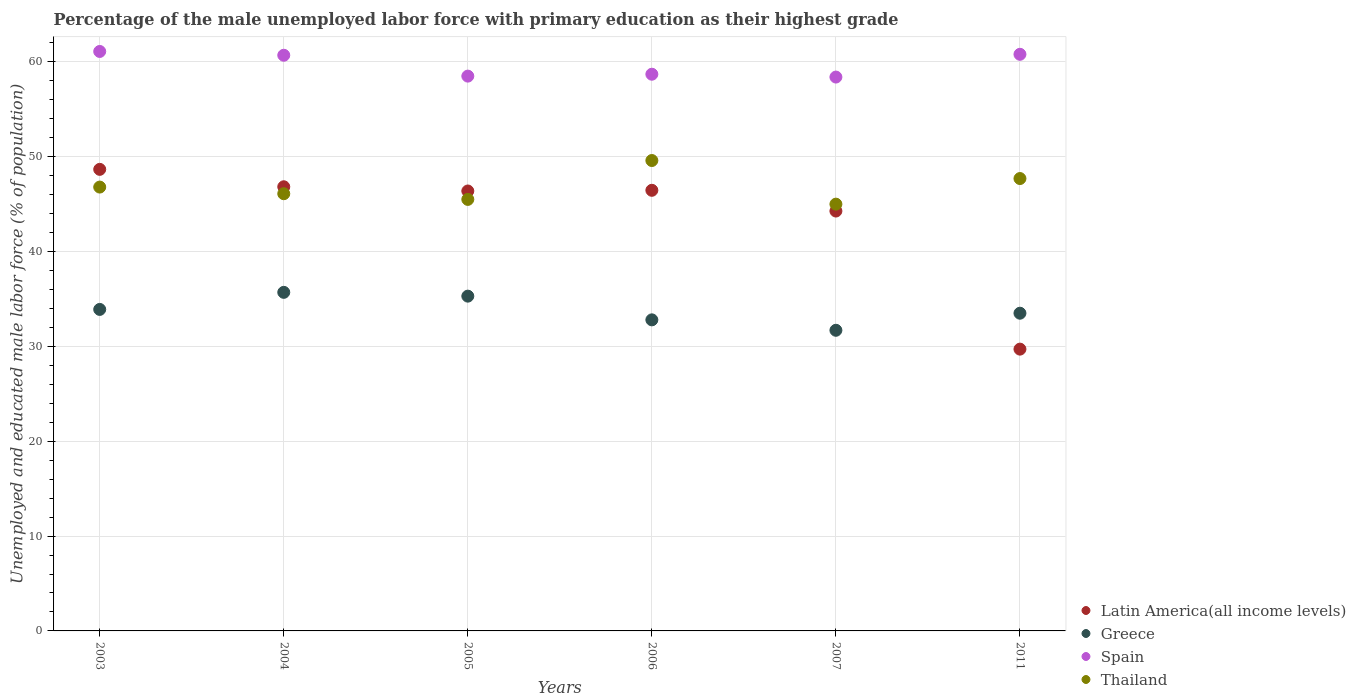What is the percentage of the unemployed male labor force with primary education in Greece in 2003?
Provide a succinct answer. 33.9. Across all years, what is the maximum percentage of the unemployed male labor force with primary education in Thailand?
Provide a succinct answer. 49.6. Across all years, what is the minimum percentage of the unemployed male labor force with primary education in Greece?
Your answer should be compact. 31.7. In which year was the percentage of the unemployed male labor force with primary education in Thailand maximum?
Offer a very short reply. 2006. What is the total percentage of the unemployed male labor force with primary education in Spain in the graph?
Offer a terse response. 358.2. What is the difference between the percentage of the unemployed male labor force with primary education in Latin America(all income levels) in 2005 and that in 2011?
Provide a short and direct response. 16.67. What is the difference between the percentage of the unemployed male labor force with primary education in Greece in 2011 and the percentage of the unemployed male labor force with primary education in Latin America(all income levels) in 2005?
Your answer should be very brief. -12.89. What is the average percentage of the unemployed male labor force with primary education in Thailand per year?
Provide a short and direct response. 46.78. In the year 2003, what is the difference between the percentage of the unemployed male labor force with primary education in Thailand and percentage of the unemployed male labor force with primary education in Greece?
Provide a short and direct response. 12.9. In how many years, is the percentage of the unemployed male labor force with primary education in Thailand greater than 42 %?
Provide a succinct answer. 6. What is the ratio of the percentage of the unemployed male labor force with primary education in Spain in 2005 to that in 2007?
Keep it short and to the point. 1. Is the percentage of the unemployed male labor force with primary education in Greece in 2004 less than that in 2005?
Make the answer very short. No. Is the difference between the percentage of the unemployed male labor force with primary education in Thailand in 2005 and 2006 greater than the difference between the percentage of the unemployed male labor force with primary education in Greece in 2005 and 2006?
Your answer should be compact. No. What is the difference between the highest and the second highest percentage of the unemployed male labor force with primary education in Greece?
Offer a terse response. 0.4. What is the difference between the highest and the lowest percentage of the unemployed male labor force with primary education in Thailand?
Keep it short and to the point. 4.6. Is it the case that in every year, the sum of the percentage of the unemployed male labor force with primary education in Spain and percentage of the unemployed male labor force with primary education in Greece  is greater than the sum of percentage of the unemployed male labor force with primary education in Latin America(all income levels) and percentage of the unemployed male labor force with primary education in Thailand?
Your answer should be compact. Yes. Is it the case that in every year, the sum of the percentage of the unemployed male labor force with primary education in Latin America(all income levels) and percentage of the unemployed male labor force with primary education in Thailand  is greater than the percentage of the unemployed male labor force with primary education in Spain?
Make the answer very short. Yes. How many years are there in the graph?
Your response must be concise. 6. Are the values on the major ticks of Y-axis written in scientific E-notation?
Make the answer very short. No. Does the graph contain any zero values?
Offer a terse response. No. Does the graph contain grids?
Give a very brief answer. Yes. How many legend labels are there?
Provide a succinct answer. 4. How are the legend labels stacked?
Your response must be concise. Vertical. What is the title of the graph?
Make the answer very short. Percentage of the male unemployed labor force with primary education as their highest grade. What is the label or title of the X-axis?
Ensure brevity in your answer.  Years. What is the label or title of the Y-axis?
Offer a very short reply. Unemployed and educated male labor force (% of population). What is the Unemployed and educated male labor force (% of population) of Latin America(all income levels) in 2003?
Offer a very short reply. 48.67. What is the Unemployed and educated male labor force (% of population) in Greece in 2003?
Offer a very short reply. 33.9. What is the Unemployed and educated male labor force (% of population) of Spain in 2003?
Offer a terse response. 61.1. What is the Unemployed and educated male labor force (% of population) of Thailand in 2003?
Provide a short and direct response. 46.8. What is the Unemployed and educated male labor force (% of population) in Latin America(all income levels) in 2004?
Make the answer very short. 46.83. What is the Unemployed and educated male labor force (% of population) of Greece in 2004?
Keep it short and to the point. 35.7. What is the Unemployed and educated male labor force (% of population) in Spain in 2004?
Your response must be concise. 60.7. What is the Unemployed and educated male labor force (% of population) of Thailand in 2004?
Give a very brief answer. 46.1. What is the Unemployed and educated male labor force (% of population) of Latin America(all income levels) in 2005?
Your answer should be compact. 46.39. What is the Unemployed and educated male labor force (% of population) of Greece in 2005?
Offer a terse response. 35.3. What is the Unemployed and educated male labor force (% of population) of Spain in 2005?
Your answer should be compact. 58.5. What is the Unemployed and educated male labor force (% of population) of Thailand in 2005?
Give a very brief answer. 45.5. What is the Unemployed and educated male labor force (% of population) in Latin America(all income levels) in 2006?
Give a very brief answer. 46.46. What is the Unemployed and educated male labor force (% of population) in Greece in 2006?
Ensure brevity in your answer.  32.8. What is the Unemployed and educated male labor force (% of population) of Spain in 2006?
Provide a short and direct response. 58.7. What is the Unemployed and educated male labor force (% of population) in Thailand in 2006?
Offer a very short reply. 49.6. What is the Unemployed and educated male labor force (% of population) in Latin America(all income levels) in 2007?
Your answer should be compact. 44.27. What is the Unemployed and educated male labor force (% of population) of Greece in 2007?
Your answer should be compact. 31.7. What is the Unemployed and educated male labor force (% of population) of Spain in 2007?
Keep it short and to the point. 58.4. What is the Unemployed and educated male labor force (% of population) of Thailand in 2007?
Offer a terse response. 45. What is the Unemployed and educated male labor force (% of population) of Latin America(all income levels) in 2011?
Provide a short and direct response. 29.71. What is the Unemployed and educated male labor force (% of population) in Greece in 2011?
Ensure brevity in your answer.  33.5. What is the Unemployed and educated male labor force (% of population) of Spain in 2011?
Provide a succinct answer. 60.8. What is the Unemployed and educated male labor force (% of population) in Thailand in 2011?
Make the answer very short. 47.7. Across all years, what is the maximum Unemployed and educated male labor force (% of population) of Latin America(all income levels)?
Provide a succinct answer. 48.67. Across all years, what is the maximum Unemployed and educated male labor force (% of population) of Greece?
Provide a short and direct response. 35.7. Across all years, what is the maximum Unemployed and educated male labor force (% of population) of Spain?
Offer a very short reply. 61.1. Across all years, what is the maximum Unemployed and educated male labor force (% of population) of Thailand?
Your answer should be very brief. 49.6. Across all years, what is the minimum Unemployed and educated male labor force (% of population) in Latin America(all income levels)?
Your answer should be compact. 29.71. Across all years, what is the minimum Unemployed and educated male labor force (% of population) of Greece?
Give a very brief answer. 31.7. Across all years, what is the minimum Unemployed and educated male labor force (% of population) of Spain?
Your response must be concise. 58.4. Across all years, what is the minimum Unemployed and educated male labor force (% of population) of Thailand?
Provide a short and direct response. 45. What is the total Unemployed and educated male labor force (% of population) in Latin America(all income levels) in the graph?
Offer a terse response. 262.33. What is the total Unemployed and educated male labor force (% of population) of Greece in the graph?
Offer a very short reply. 202.9. What is the total Unemployed and educated male labor force (% of population) in Spain in the graph?
Give a very brief answer. 358.2. What is the total Unemployed and educated male labor force (% of population) of Thailand in the graph?
Provide a succinct answer. 280.7. What is the difference between the Unemployed and educated male labor force (% of population) in Latin America(all income levels) in 2003 and that in 2004?
Keep it short and to the point. 1.84. What is the difference between the Unemployed and educated male labor force (% of population) of Spain in 2003 and that in 2004?
Give a very brief answer. 0.4. What is the difference between the Unemployed and educated male labor force (% of population) of Thailand in 2003 and that in 2004?
Make the answer very short. 0.7. What is the difference between the Unemployed and educated male labor force (% of population) of Latin America(all income levels) in 2003 and that in 2005?
Ensure brevity in your answer.  2.28. What is the difference between the Unemployed and educated male labor force (% of population) in Spain in 2003 and that in 2005?
Provide a short and direct response. 2.6. What is the difference between the Unemployed and educated male labor force (% of population) in Latin America(all income levels) in 2003 and that in 2006?
Your response must be concise. 2.21. What is the difference between the Unemployed and educated male labor force (% of population) in Spain in 2003 and that in 2006?
Your response must be concise. 2.4. What is the difference between the Unemployed and educated male labor force (% of population) in Thailand in 2003 and that in 2006?
Make the answer very short. -2.8. What is the difference between the Unemployed and educated male labor force (% of population) of Latin America(all income levels) in 2003 and that in 2007?
Ensure brevity in your answer.  4.4. What is the difference between the Unemployed and educated male labor force (% of population) in Greece in 2003 and that in 2007?
Your response must be concise. 2.2. What is the difference between the Unemployed and educated male labor force (% of population) of Spain in 2003 and that in 2007?
Provide a short and direct response. 2.7. What is the difference between the Unemployed and educated male labor force (% of population) of Latin America(all income levels) in 2003 and that in 2011?
Make the answer very short. 18.96. What is the difference between the Unemployed and educated male labor force (% of population) in Latin America(all income levels) in 2004 and that in 2005?
Provide a short and direct response. 0.45. What is the difference between the Unemployed and educated male labor force (% of population) of Spain in 2004 and that in 2005?
Provide a short and direct response. 2.2. What is the difference between the Unemployed and educated male labor force (% of population) in Latin America(all income levels) in 2004 and that in 2006?
Your response must be concise. 0.37. What is the difference between the Unemployed and educated male labor force (% of population) of Greece in 2004 and that in 2006?
Your answer should be very brief. 2.9. What is the difference between the Unemployed and educated male labor force (% of population) of Spain in 2004 and that in 2006?
Give a very brief answer. 2. What is the difference between the Unemployed and educated male labor force (% of population) in Latin America(all income levels) in 2004 and that in 2007?
Make the answer very short. 2.56. What is the difference between the Unemployed and educated male labor force (% of population) of Greece in 2004 and that in 2007?
Keep it short and to the point. 4. What is the difference between the Unemployed and educated male labor force (% of population) of Spain in 2004 and that in 2007?
Offer a very short reply. 2.3. What is the difference between the Unemployed and educated male labor force (% of population) in Latin America(all income levels) in 2004 and that in 2011?
Offer a very short reply. 17.12. What is the difference between the Unemployed and educated male labor force (% of population) of Spain in 2004 and that in 2011?
Ensure brevity in your answer.  -0.1. What is the difference between the Unemployed and educated male labor force (% of population) in Latin America(all income levels) in 2005 and that in 2006?
Provide a succinct answer. -0.07. What is the difference between the Unemployed and educated male labor force (% of population) in Greece in 2005 and that in 2006?
Offer a terse response. 2.5. What is the difference between the Unemployed and educated male labor force (% of population) of Thailand in 2005 and that in 2006?
Provide a succinct answer. -4.1. What is the difference between the Unemployed and educated male labor force (% of population) in Latin America(all income levels) in 2005 and that in 2007?
Offer a terse response. 2.11. What is the difference between the Unemployed and educated male labor force (% of population) in Spain in 2005 and that in 2007?
Your answer should be compact. 0.1. What is the difference between the Unemployed and educated male labor force (% of population) in Latin America(all income levels) in 2005 and that in 2011?
Make the answer very short. 16.67. What is the difference between the Unemployed and educated male labor force (% of population) of Greece in 2005 and that in 2011?
Make the answer very short. 1.8. What is the difference between the Unemployed and educated male labor force (% of population) in Latin America(all income levels) in 2006 and that in 2007?
Your response must be concise. 2.19. What is the difference between the Unemployed and educated male labor force (% of population) in Spain in 2006 and that in 2007?
Ensure brevity in your answer.  0.3. What is the difference between the Unemployed and educated male labor force (% of population) in Thailand in 2006 and that in 2007?
Offer a terse response. 4.6. What is the difference between the Unemployed and educated male labor force (% of population) of Latin America(all income levels) in 2006 and that in 2011?
Offer a terse response. 16.75. What is the difference between the Unemployed and educated male labor force (% of population) of Greece in 2006 and that in 2011?
Keep it short and to the point. -0.7. What is the difference between the Unemployed and educated male labor force (% of population) of Spain in 2006 and that in 2011?
Your response must be concise. -2.1. What is the difference between the Unemployed and educated male labor force (% of population) of Latin America(all income levels) in 2007 and that in 2011?
Offer a very short reply. 14.56. What is the difference between the Unemployed and educated male labor force (% of population) of Greece in 2007 and that in 2011?
Your answer should be very brief. -1.8. What is the difference between the Unemployed and educated male labor force (% of population) in Latin America(all income levels) in 2003 and the Unemployed and educated male labor force (% of population) in Greece in 2004?
Keep it short and to the point. 12.97. What is the difference between the Unemployed and educated male labor force (% of population) of Latin America(all income levels) in 2003 and the Unemployed and educated male labor force (% of population) of Spain in 2004?
Your answer should be compact. -12.03. What is the difference between the Unemployed and educated male labor force (% of population) in Latin America(all income levels) in 2003 and the Unemployed and educated male labor force (% of population) in Thailand in 2004?
Offer a very short reply. 2.57. What is the difference between the Unemployed and educated male labor force (% of population) of Greece in 2003 and the Unemployed and educated male labor force (% of population) of Spain in 2004?
Your answer should be very brief. -26.8. What is the difference between the Unemployed and educated male labor force (% of population) in Spain in 2003 and the Unemployed and educated male labor force (% of population) in Thailand in 2004?
Give a very brief answer. 15. What is the difference between the Unemployed and educated male labor force (% of population) of Latin America(all income levels) in 2003 and the Unemployed and educated male labor force (% of population) of Greece in 2005?
Keep it short and to the point. 13.37. What is the difference between the Unemployed and educated male labor force (% of population) in Latin America(all income levels) in 2003 and the Unemployed and educated male labor force (% of population) in Spain in 2005?
Your answer should be compact. -9.83. What is the difference between the Unemployed and educated male labor force (% of population) of Latin America(all income levels) in 2003 and the Unemployed and educated male labor force (% of population) of Thailand in 2005?
Your response must be concise. 3.17. What is the difference between the Unemployed and educated male labor force (% of population) in Greece in 2003 and the Unemployed and educated male labor force (% of population) in Spain in 2005?
Your answer should be very brief. -24.6. What is the difference between the Unemployed and educated male labor force (% of population) of Spain in 2003 and the Unemployed and educated male labor force (% of population) of Thailand in 2005?
Provide a succinct answer. 15.6. What is the difference between the Unemployed and educated male labor force (% of population) in Latin America(all income levels) in 2003 and the Unemployed and educated male labor force (% of population) in Greece in 2006?
Provide a short and direct response. 15.87. What is the difference between the Unemployed and educated male labor force (% of population) of Latin America(all income levels) in 2003 and the Unemployed and educated male labor force (% of population) of Spain in 2006?
Give a very brief answer. -10.03. What is the difference between the Unemployed and educated male labor force (% of population) in Latin America(all income levels) in 2003 and the Unemployed and educated male labor force (% of population) in Thailand in 2006?
Offer a very short reply. -0.93. What is the difference between the Unemployed and educated male labor force (% of population) of Greece in 2003 and the Unemployed and educated male labor force (% of population) of Spain in 2006?
Ensure brevity in your answer.  -24.8. What is the difference between the Unemployed and educated male labor force (% of population) of Greece in 2003 and the Unemployed and educated male labor force (% of population) of Thailand in 2006?
Offer a terse response. -15.7. What is the difference between the Unemployed and educated male labor force (% of population) of Latin America(all income levels) in 2003 and the Unemployed and educated male labor force (% of population) of Greece in 2007?
Your response must be concise. 16.97. What is the difference between the Unemployed and educated male labor force (% of population) of Latin America(all income levels) in 2003 and the Unemployed and educated male labor force (% of population) of Spain in 2007?
Provide a short and direct response. -9.73. What is the difference between the Unemployed and educated male labor force (% of population) in Latin America(all income levels) in 2003 and the Unemployed and educated male labor force (% of population) in Thailand in 2007?
Keep it short and to the point. 3.67. What is the difference between the Unemployed and educated male labor force (% of population) in Greece in 2003 and the Unemployed and educated male labor force (% of population) in Spain in 2007?
Your answer should be compact. -24.5. What is the difference between the Unemployed and educated male labor force (% of population) in Latin America(all income levels) in 2003 and the Unemployed and educated male labor force (% of population) in Greece in 2011?
Offer a very short reply. 15.17. What is the difference between the Unemployed and educated male labor force (% of population) of Latin America(all income levels) in 2003 and the Unemployed and educated male labor force (% of population) of Spain in 2011?
Your response must be concise. -12.13. What is the difference between the Unemployed and educated male labor force (% of population) in Latin America(all income levels) in 2003 and the Unemployed and educated male labor force (% of population) in Thailand in 2011?
Your response must be concise. 0.97. What is the difference between the Unemployed and educated male labor force (% of population) in Greece in 2003 and the Unemployed and educated male labor force (% of population) in Spain in 2011?
Offer a terse response. -26.9. What is the difference between the Unemployed and educated male labor force (% of population) of Spain in 2003 and the Unemployed and educated male labor force (% of population) of Thailand in 2011?
Provide a succinct answer. 13.4. What is the difference between the Unemployed and educated male labor force (% of population) in Latin America(all income levels) in 2004 and the Unemployed and educated male labor force (% of population) in Greece in 2005?
Keep it short and to the point. 11.53. What is the difference between the Unemployed and educated male labor force (% of population) in Latin America(all income levels) in 2004 and the Unemployed and educated male labor force (% of population) in Spain in 2005?
Your answer should be very brief. -11.67. What is the difference between the Unemployed and educated male labor force (% of population) of Latin America(all income levels) in 2004 and the Unemployed and educated male labor force (% of population) of Thailand in 2005?
Your answer should be compact. 1.33. What is the difference between the Unemployed and educated male labor force (% of population) in Greece in 2004 and the Unemployed and educated male labor force (% of population) in Spain in 2005?
Ensure brevity in your answer.  -22.8. What is the difference between the Unemployed and educated male labor force (% of population) of Greece in 2004 and the Unemployed and educated male labor force (% of population) of Thailand in 2005?
Give a very brief answer. -9.8. What is the difference between the Unemployed and educated male labor force (% of population) in Latin America(all income levels) in 2004 and the Unemployed and educated male labor force (% of population) in Greece in 2006?
Provide a short and direct response. 14.03. What is the difference between the Unemployed and educated male labor force (% of population) in Latin America(all income levels) in 2004 and the Unemployed and educated male labor force (% of population) in Spain in 2006?
Offer a very short reply. -11.87. What is the difference between the Unemployed and educated male labor force (% of population) of Latin America(all income levels) in 2004 and the Unemployed and educated male labor force (% of population) of Thailand in 2006?
Ensure brevity in your answer.  -2.77. What is the difference between the Unemployed and educated male labor force (% of population) of Greece in 2004 and the Unemployed and educated male labor force (% of population) of Spain in 2006?
Keep it short and to the point. -23. What is the difference between the Unemployed and educated male labor force (% of population) of Spain in 2004 and the Unemployed and educated male labor force (% of population) of Thailand in 2006?
Your answer should be compact. 11.1. What is the difference between the Unemployed and educated male labor force (% of population) in Latin America(all income levels) in 2004 and the Unemployed and educated male labor force (% of population) in Greece in 2007?
Offer a very short reply. 15.13. What is the difference between the Unemployed and educated male labor force (% of population) in Latin America(all income levels) in 2004 and the Unemployed and educated male labor force (% of population) in Spain in 2007?
Offer a very short reply. -11.57. What is the difference between the Unemployed and educated male labor force (% of population) of Latin America(all income levels) in 2004 and the Unemployed and educated male labor force (% of population) of Thailand in 2007?
Your answer should be compact. 1.83. What is the difference between the Unemployed and educated male labor force (% of population) of Greece in 2004 and the Unemployed and educated male labor force (% of population) of Spain in 2007?
Give a very brief answer. -22.7. What is the difference between the Unemployed and educated male labor force (% of population) of Greece in 2004 and the Unemployed and educated male labor force (% of population) of Thailand in 2007?
Offer a very short reply. -9.3. What is the difference between the Unemployed and educated male labor force (% of population) of Spain in 2004 and the Unemployed and educated male labor force (% of population) of Thailand in 2007?
Provide a short and direct response. 15.7. What is the difference between the Unemployed and educated male labor force (% of population) of Latin America(all income levels) in 2004 and the Unemployed and educated male labor force (% of population) of Greece in 2011?
Your answer should be very brief. 13.33. What is the difference between the Unemployed and educated male labor force (% of population) of Latin America(all income levels) in 2004 and the Unemployed and educated male labor force (% of population) of Spain in 2011?
Offer a terse response. -13.97. What is the difference between the Unemployed and educated male labor force (% of population) of Latin America(all income levels) in 2004 and the Unemployed and educated male labor force (% of population) of Thailand in 2011?
Provide a short and direct response. -0.87. What is the difference between the Unemployed and educated male labor force (% of population) in Greece in 2004 and the Unemployed and educated male labor force (% of population) in Spain in 2011?
Make the answer very short. -25.1. What is the difference between the Unemployed and educated male labor force (% of population) in Spain in 2004 and the Unemployed and educated male labor force (% of population) in Thailand in 2011?
Your response must be concise. 13. What is the difference between the Unemployed and educated male labor force (% of population) of Latin America(all income levels) in 2005 and the Unemployed and educated male labor force (% of population) of Greece in 2006?
Your response must be concise. 13.59. What is the difference between the Unemployed and educated male labor force (% of population) in Latin America(all income levels) in 2005 and the Unemployed and educated male labor force (% of population) in Spain in 2006?
Offer a terse response. -12.31. What is the difference between the Unemployed and educated male labor force (% of population) in Latin America(all income levels) in 2005 and the Unemployed and educated male labor force (% of population) in Thailand in 2006?
Ensure brevity in your answer.  -3.21. What is the difference between the Unemployed and educated male labor force (% of population) of Greece in 2005 and the Unemployed and educated male labor force (% of population) of Spain in 2006?
Ensure brevity in your answer.  -23.4. What is the difference between the Unemployed and educated male labor force (% of population) in Greece in 2005 and the Unemployed and educated male labor force (% of population) in Thailand in 2006?
Keep it short and to the point. -14.3. What is the difference between the Unemployed and educated male labor force (% of population) in Spain in 2005 and the Unemployed and educated male labor force (% of population) in Thailand in 2006?
Offer a very short reply. 8.9. What is the difference between the Unemployed and educated male labor force (% of population) of Latin America(all income levels) in 2005 and the Unemployed and educated male labor force (% of population) of Greece in 2007?
Offer a very short reply. 14.69. What is the difference between the Unemployed and educated male labor force (% of population) of Latin America(all income levels) in 2005 and the Unemployed and educated male labor force (% of population) of Spain in 2007?
Provide a short and direct response. -12.01. What is the difference between the Unemployed and educated male labor force (% of population) in Latin America(all income levels) in 2005 and the Unemployed and educated male labor force (% of population) in Thailand in 2007?
Give a very brief answer. 1.39. What is the difference between the Unemployed and educated male labor force (% of population) of Greece in 2005 and the Unemployed and educated male labor force (% of population) of Spain in 2007?
Your answer should be compact. -23.1. What is the difference between the Unemployed and educated male labor force (% of population) of Latin America(all income levels) in 2005 and the Unemployed and educated male labor force (% of population) of Greece in 2011?
Provide a short and direct response. 12.89. What is the difference between the Unemployed and educated male labor force (% of population) in Latin America(all income levels) in 2005 and the Unemployed and educated male labor force (% of population) in Spain in 2011?
Your answer should be very brief. -14.41. What is the difference between the Unemployed and educated male labor force (% of population) in Latin America(all income levels) in 2005 and the Unemployed and educated male labor force (% of population) in Thailand in 2011?
Offer a terse response. -1.31. What is the difference between the Unemployed and educated male labor force (% of population) in Greece in 2005 and the Unemployed and educated male labor force (% of population) in Spain in 2011?
Offer a terse response. -25.5. What is the difference between the Unemployed and educated male labor force (% of population) of Greece in 2005 and the Unemployed and educated male labor force (% of population) of Thailand in 2011?
Offer a very short reply. -12.4. What is the difference between the Unemployed and educated male labor force (% of population) in Spain in 2005 and the Unemployed and educated male labor force (% of population) in Thailand in 2011?
Make the answer very short. 10.8. What is the difference between the Unemployed and educated male labor force (% of population) in Latin America(all income levels) in 2006 and the Unemployed and educated male labor force (% of population) in Greece in 2007?
Keep it short and to the point. 14.76. What is the difference between the Unemployed and educated male labor force (% of population) in Latin America(all income levels) in 2006 and the Unemployed and educated male labor force (% of population) in Spain in 2007?
Your answer should be very brief. -11.94. What is the difference between the Unemployed and educated male labor force (% of population) of Latin America(all income levels) in 2006 and the Unemployed and educated male labor force (% of population) of Thailand in 2007?
Your answer should be very brief. 1.46. What is the difference between the Unemployed and educated male labor force (% of population) in Greece in 2006 and the Unemployed and educated male labor force (% of population) in Spain in 2007?
Your answer should be compact. -25.6. What is the difference between the Unemployed and educated male labor force (% of population) in Greece in 2006 and the Unemployed and educated male labor force (% of population) in Thailand in 2007?
Keep it short and to the point. -12.2. What is the difference between the Unemployed and educated male labor force (% of population) in Spain in 2006 and the Unemployed and educated male labor force (% of population) in Thailand in 2007?
Offer a very short reply. 13.7. What is the difference between the Unemployed and educated male labor force (% of population) in Latin America(all income levels) in 2006 and the Unemployed and educated male labor force (% of population) in Greece in 2011?
Keep it short and to the point. 12.96. What is the difference between the Unemployed and educated male labor force (% of population) of Latin America(all income levels) in 2006 and the Unemployed and educated male labor force (% of population) of Spain in 2011?
Provide a short and direct response. -14.34. What is the difference between the Unemployed and educated male labor force (% of population) in Latin America(all income levels) in 2006 and the Unemployed and educated male labor force (% of population) in Thailand in 2011?
Offer a very short reply. -1.24. What is the difference between the Unemployed and educated male labor force (% of population) in Greece in 2006 and the Unemployed and educated male labor force (% of population) in Thailand in 2011?
Make the answer very short. -14.9. What is the difference between the Unemployed and educated male labor force (% of population) in Latin America(all income levels) in 2007 and the Unemployed and educated male labor force (% of population) in Greece in 2011?
Your answer should be very brief. 10.77. What is the difference between the Unemployed and educated male labor force (% of population) of Latin America(all income levels) in 2007 and the Unemployed and educated male labor force (% of population) of Spain in 2011?
Offer a very short reply. -16.53. What is the difference between the Unemployed and educated male labor force (% of population) in Latin America(all income levels) in 2007 and the Unemployed and educated male labor force (% of population) in Thailand in 2011?
Give a very brief answer. -3.43. What is the difference between the Unemployed and educated male labor force (% of population) in Greece in 2007 and the Unemployed and educated male labor force (% of population) in Spain in 2011?
Keep it short and to the point. -29.1. What is the difference between the Unemployed and educated male labor force (% of population) of Greece in 2007 and the Unemployed and educated male labor force (% of population) of Thailand in 2011?
Provide a succinct answer. -16. What is the average Unemployed and educated male labor force (% of population) of Latin America(all income levels) per year?
Your answer should be compact. 43.72. What is the average Unemployed and educated male labor force (% of population) in Greece per year?
Offer a terse response. 33.82. What is the average Unemployed and educated male labor force (% of population) of Spain per year?
Your response must be concise. 59.7. What is the average Unemployed and educated male labor force (% of population) in Thailand per year?
Your answer should be very brief. 46.78. In the year 2003, what is the difference between the Unemployed and educated male labor force (% of population) of Latin America(all income levels) and Unemployed and educated male labor force (% of population) of Greece?
Your response must be concise. 14.77. In the year 2003, what is the difference between the Unemployed and educated male labor force (% of population) in Latin America(all income levels) and Unemployed and educated male labor force (% of population) in Spain?
Your answer should be very brief. -12.43. In the year 2003, what is the difference between the Unemployed and educated male labor force (% of population) in Latin America(all income levels) and Unemployed and educated male labor force (% of population) in Thailand?
Give a very brief answer. 1.87. In the year 2003, what is the difference between the Unemployed and educated male labor force (% of population) of Greece and Unemployed and educated male labor force (% of population) of Spain?
Provide a succinct answer. -27.2. In the year 2004, what is the difference between the Unemployed and educated male labor force (% of population) in Latin America(all income levels) and Unemployed and educated male labor force (% of population) in Greece?
Your answer should be very brief. 11.13. In the year 2004, what is the difference between the Unemployed and educated male labor force (% of population) of Latin America(all income levels) and Unemployed and educated male labor force (% of population) of Spain?
Provide a short and direct response. -13.87. In the year 2004, what is the difference between the Unemployed and educated male labor force (% of population) of Latin America(all income levels) and Unemployed and educated male labor force (% of population) of Thailand?
Ensure brevity in your answer.  0.73. In the year 2004, what is the difference between the Unemployed and educated male labor force (% of population) in Greece and Unemployed and educated male labor force (% of population) in Spain?
Your response must be concise. -25. In the year 2004, what is the difference between the Unemployed and educated male labor force (% of population) in Spain and Unemployed and educated male labor force (% of population) in Thailand?
Your answer should be very brief. 14.6. In the year 2005, what is the difference between the Unemployed and educated male labor force (% of population) in Latin America(all income levels) and Unemployed and educated male labor force (% of population) in Greece?
Ensure brevity in your answer.  11.09. In the year 2005, what is the difference between the Unemployed and educated male labor force (% of population) in Latin America(all income levels) and Unemployed and educated male labor force (% of population) in Spain?
Your answer should be compact. -12.11. In the year 2005, what is the difference between the Unemployed and educated male labor force (% of population) of Latin America(all income levels) and Unemployed and educated male labor force (% of population) of Thailand?
Your answer should be very brief. 0.89. In the year 2005, what is the difference between the Unemployed and educated male labor force (% of population) in Greece and Unemployed and educated male labor force (% of population) in Spain?
Make the answer very short. -23.2. In the year 2006, what is the difference between the Unemployed and educated male labor force (% of population) of Latin America(all income levels) and Unemployed and educated male labor force (% of population) of Greece?
Make the answer very short. 13.66. In the year 2006, what is the difference between the Unemployed and educated male labor force (% of population) in Latin America(all income levels) and Unemployed and educated male labor force (% of population) in Spain?
Your answer should be very brief. -12.24. In the year 2006, what is the difference between the Unemployed and educated male labor force (% of population) in Latin America(all income levels) and Unemployed and educated male labor force (% of population) in Thailand?
Provide a short and direct response. -3.14. In the year 2006, what is the difference between the Unemployed and educated male labor force (% of population) of Greece and Unemployed and educated male labor force (% of population) of Spain?
Provide a short and direct response. -25.9. In the year 2006, what is the difference between the Unemployed and educated male labor force (% of population) in Greece and Unemployed and educated male labor force (% of population) in Thailand?
Offer a very short reply. -16.8. In the year 2007, what is the difference between the Unemployed and educated male labor force (% of population) in Latin America(all income levels) and Unemployed and educated male labor force (% of population) in Greece?
Your answer should be compact. 12.57. In the year 2007, what is the difference between the Unemployed and educated male labor force (% of population) in Latin America(all income levels) and Unemployed and educated male labor force (% of population) in Spain?
Your answer should be very brief. -14.13. In the year 2007, what is the difference between the Unemployed and educated male labor force (% of population) of Latin America(all income levels) and Unemployed and educated male labor force (% of population) of Thailand?
Provide a succinct answer. -0.73. In the year 2007, what is the difference between the Unemployed and educated male labor force (% of population) in Greece and Unemployed and educated male labor force (% of population) in Spain?
Your answer should be compact. -26.7. In the year 2007, what is the difference between the Unemployed and educated male labor force (% of population) in Greece and Unemployed and educated male labor force (% of population) in Thailand?
Offer a terse response. -13.3. In the year 2007, what is the difference between the Unemployed and educated male labor force (% of population) in Spain and Unemployed and educated male labor force (% of population) in Thailand?
Provide a short and direct response. 13.4. In the year 2011, what is the difference between the Unemployed and educated male labor force (% of population) in Latin America(all income levels) and Unemployed and educated male labor force (% of population) in Greece?
Offer a very short reply. -3.79. In the year 2011, what is the difference between the Unemployed and educated male labor force (% of population) of Latin America(all income levels) and Unemployed and educated male labor force (% of population) of Spain?
Provide a succinct answer. -31.09. In the year 2011, what is the difference between the Unemployed and educated male labor force (% of population) of Latin America(all income levels) and Unemployed and educated male labor force (% of population) of Thailand?
Make the answer very short. -17.99. In the year 2011, what is the difference between the Unemployed and educated male labor force (% of population) of Greece and Unemployed and educated male labor force (% of population) of Spain?
Provide a short and direct response. -27.3. What is the ratio of the Unemployed and educated male labor force (% of population) in Latin America(all income levels) in 2003 to that in 2004?
Your response must be concise. 1.04. What is the ratio of the Unemployed and educated male labor force (% of population) in Greece in 2003 to that in 2004?
Offer a terse response. 0.95. What is the ratio of the Unemployed and educated male labor force (% of population) of Spain in 2003 to that in 2004?
Your answer should be very brief. 1.01. What is the ratio of the Unemployed and educated male labor force (% of population) of Thailand in 2003 to that in 2004?
Ensure brevity in your answer.  1.02. What is the ratio of the Unemployed and educated male labor force (% of population) of Latin America(all income levels) in 2003 to that in 2005?
Offer a very short reply. 1.05. What is the ratio of the Unemployed and educated male labor force (% of population) of Greece in 2003 to that in 2005?
Provide a succinct answer. 0.96. What is the ratio of the Unemployed and educated male labor force (% of population) in Spain in 2003 to that in 2005?
Ensure brevity in your answer.  1.04. What is the ratio of the Unemployed and educated male labor force (% of population) in Thailand in 2003 to that in 2005?
Keep it short and to the point. 1.03. What is the ratio of the Unemployed and educated male labor force (% of population) in Latin America(all income levels) in 2003 to that in 2006?
Your answer should be very brief. 1.05. What is the ratio of the Unemployed and educated male labor force (% of population) in Greece in 2003 to that in 2006?
Keep it short and to the point. 1.03. What is the ratio of the Unemployed and educated male labor force (% of population) in Spain in 2003 to that in 2006?
Ensure brevity in your answer.  1.04. What is the ratio of the Unemployed and educated male labor force (% of population) in Thailand in 2003 to that in 2006?
Provide a succinct answer. 0.94. What is the ratio of the Unemployed and educated male labor force (% of population) in Latin America(all income levels) in 2003 to that in 2007?
Provide a short and direct response. 1.1. What is the ratio of the Unemployed and educated male labor force (% of population) of Greece in 2003 to that in 2007?
Ensure brevity in your answer.  1.07. What is the ratio of the Unemployed and educated male labor force (% of population) of Spain in 2003 to that in 2007?
Ensure brevity in your answer.  1.05. What is the ratio of the Unemployed and educated male labor force (% of population) of Thailand in 2003 to that in 2007?
Make the answer very short. 1.04. What is the ratio of the Unemployed and educated male labor force (% of population) of Latin America(all income levels) in 2003 to that in 2011?
Ensure brevity in your answer.  1.64. What is the ratio of the Unemployed and educated male labor force (% of population) of Greece in 2003 to that in 2011?
Provide a short and direct response. 1.01. What is the ratio of the Unemployed and educated male labor force (% of population) of Spain in 2003 to that in 2011?
Your answer should be compact. 1. What is the ratio of the Unemployed and educated male labor force (% of population) of Thailand in 2003 to that in 2011?
Your answer should be very brief. 0.98. What is the ratio of the Unemployed and educated male labor force (% of population) of Latin America(all income levels) in 2004 to that in 2005?
Your answer should be compact. 1.01. What is the ratio of the Unemployed and educated male labor force (% of population) in Greece in 2004 to that in 2005?
Offer a very short reply. 1.01. What is the ratio of the Unemployed and educated male labor force (% of population) of Spain in 2004 to that in 2005?
Keep it short and to the point. 1.04. What is the ratio of the Unemployed and educated male labor force (% of population) of Thailand in 2004 to that in 2005?
Keep it short and to the point. 1.01. What is the ratio of the Unemployed and educated male labor force (% of population) in Greece in 2004 to that in 2006?
Keep it short and to the point. 1.09. What is the ratio of the Unemployed and educated male labor force (% of population) of Spain in 2004 to that in 2006?
Keep it short and to the point. 1.03. What is the ratio of the Unemployed and educated male labor force (% of population) in Thailand in 2004 to that in 2006?
Your answer should be very brief. 0.93. What is the ratio of the Unemployed and educated male labor force (% of population) of Latin America(all income levels) in 2004 to that in 2007?
Your answer should be very brief. 1.06. What is the ratio of the Unemployed and educated male labor force (% of population) of Greece in 2004 to that in 2007?
Give a very brief answer. 1.13. What is the ratio of the Unemployed and educated male labor force (% of population) of Spain in 2004 to that in 2007?
Your answer should be very brief. 1.04. What is the ratio of the Unemployed and educated male labor force (% of population) of Thailand in 2004 to that in 2007?
Provide a succinct answer. 1.02. What is the ratio of the Unemployed and educated male labor force (% of population) in Latin America(all income levels) in 2004 to that in 2011?
Ensure brevity in your answer.  1.58. What is the ratio of the Unemployed and educated male labor force (% of population) in Greece in 2004 to that in 2011?
Provide a succinct answer. 1.07. What is the ratio of the Unemployed and educated male labor force (% of population) of Spain in 2004 to that in 2011?
Your response must be concise. 1. What is the ratio of the Unemployed and educated male labor force (% of population) in Thailand in 2004 to that in 2011?
Offer a very short reply. 0.97. What is the ratio of the Unemployed and educated male labor force (% of population) of Latin America(all income levels) in 2005 to that in 2006?
Keep it short and to the point. 1. What is the ratio of the Unemployed and educated male labor force (% of population) in Greece in 2005 to that in 2006?
Make the answer very short. 1.08. What is the ratio of the Unemployed and educated male labor force (% of population) in Spain in 2005 to that in 2006?
Your answer should be compact. 1. What is the ratio of the Unemployed and educated male labor force (% of population) of Thailand in 2005 to that in 2006?
Your answer should be compact. 0.92. What is the ratio of the Unemployed and educated male labor force (% of population) in Latin America(all income levels) in 2005 to that in 2007?
Offer a terse response. 1.05. What is the ratio of the Unemployed and educated male labor force (% of population) in Greece in 2005 to that in 2007?
Provide a succinct answer. 1.11. What is the ratio of the Unemployed and educated male labor force (% of population) of Spain in 2005 to that in 2007?
Offer a very short reply. 1. What is the ratio of the Unemployed and educated male labor force (% of population) in Thailand in 2005 to that in 2007?
Keep it short and to the point. 1.01. What is the ratio of the Unemployed and educated male labor force (% of population) in Latin America(all income levels) in 2005 to that in 2011?
Ensure brevity in your answer.  1.56. What is the ratio of the Unemployed and educated male labor force (% of population) of Greece in 2005 to that in 2011?
Your answer should be very brief. 1.05. What is the ratio of the Unemployed and educated male labor force (% of population) in Spain in 2005 to that in 2011?
Your answer should be very brief. 0.96. What is the ratio of the Unemployed and educated male labor force (% of population) of Thailand in 2005 to that in 2011?
Your response must be concise. 0.95. What is the ratio of the Unemployed and educated male labor force (% of population) in Latin America(all income levels) in 2006 to that in 2007?
Your response must be concise. 1.05. What is the ratio of the Unemployed and educated male labor force (% of population) in Greece in 2006 to that in 2007?
Keep it short and to the point. 1.03. What is the ratio of the Unemployed and educated male labor force (% of population) of Spain in 2006 to that in 2007?
Your response must be concise. 1.01. What is the ratio of the Unemployed and educated male labor force (% of population) in Thailand in 2006 to that in 2007?
Your answer should be very brief. 1.1. What is the ratio of the Unemployed and educated male labor force (% of population) of Latin America(all income levels) in 2006 to that in 2011?
Give a very brief answer. 1.56. What is the ratio of the Unemployed and educated male labor force (% of population) in Greece in 2006 to that in 2011?
Your answer should be compact. 0.98. What is the ratio of the Unemployed and educated male labor force (% of population) of Spain in 2006 to that in 2011?
Make the answer very short. 0.97. What is the ratio of the Unemployed and educated male labor force (% of population) of Thailand in 2006 to that in 2011?
Make the answer very short. 1.04. What is the ratio of the Unemployed and educated male labor force (% of population) of Latin America(all income levels) in 2007 to that in 2011?
Keep it short and to the point. 1.49. What is the ratio of the Unemployed and educated male labor force (% of population) of Greece in 2007 to that in 2011?
Offer a terse response. 0.95. What is the ratio of the Unemployed and educated male labor force (% of population) of Spain in 2007 to that in 2011?
Ensure brevity in your answer.  0.96. What is the ratio of the Unemployed and educated male labor force (% of population) in Thailand in 2007 to that in 2011?
Give a very brief answer. 0.94. What is the difference between the highest and the second highest Unemployed and educated male labor force (% of population) in Latin America(all income levels)?
Your answer should be compact. 1.84. What is the difference between the highest and the second highest Unemployed and educated male labor force (% of population) in Greece?
Provide a succinct answer. 0.4. What is the difference between the highest and the second highest Unemployed and educated male labor force (% of population) in Spain?
Provide a short and direct response. 0.3. What is the difference between the highest and the lowest Unemployed and educated male labor force (% of population) in Latin America(all income levels)?
Provide a short and direct response. 18.96. 